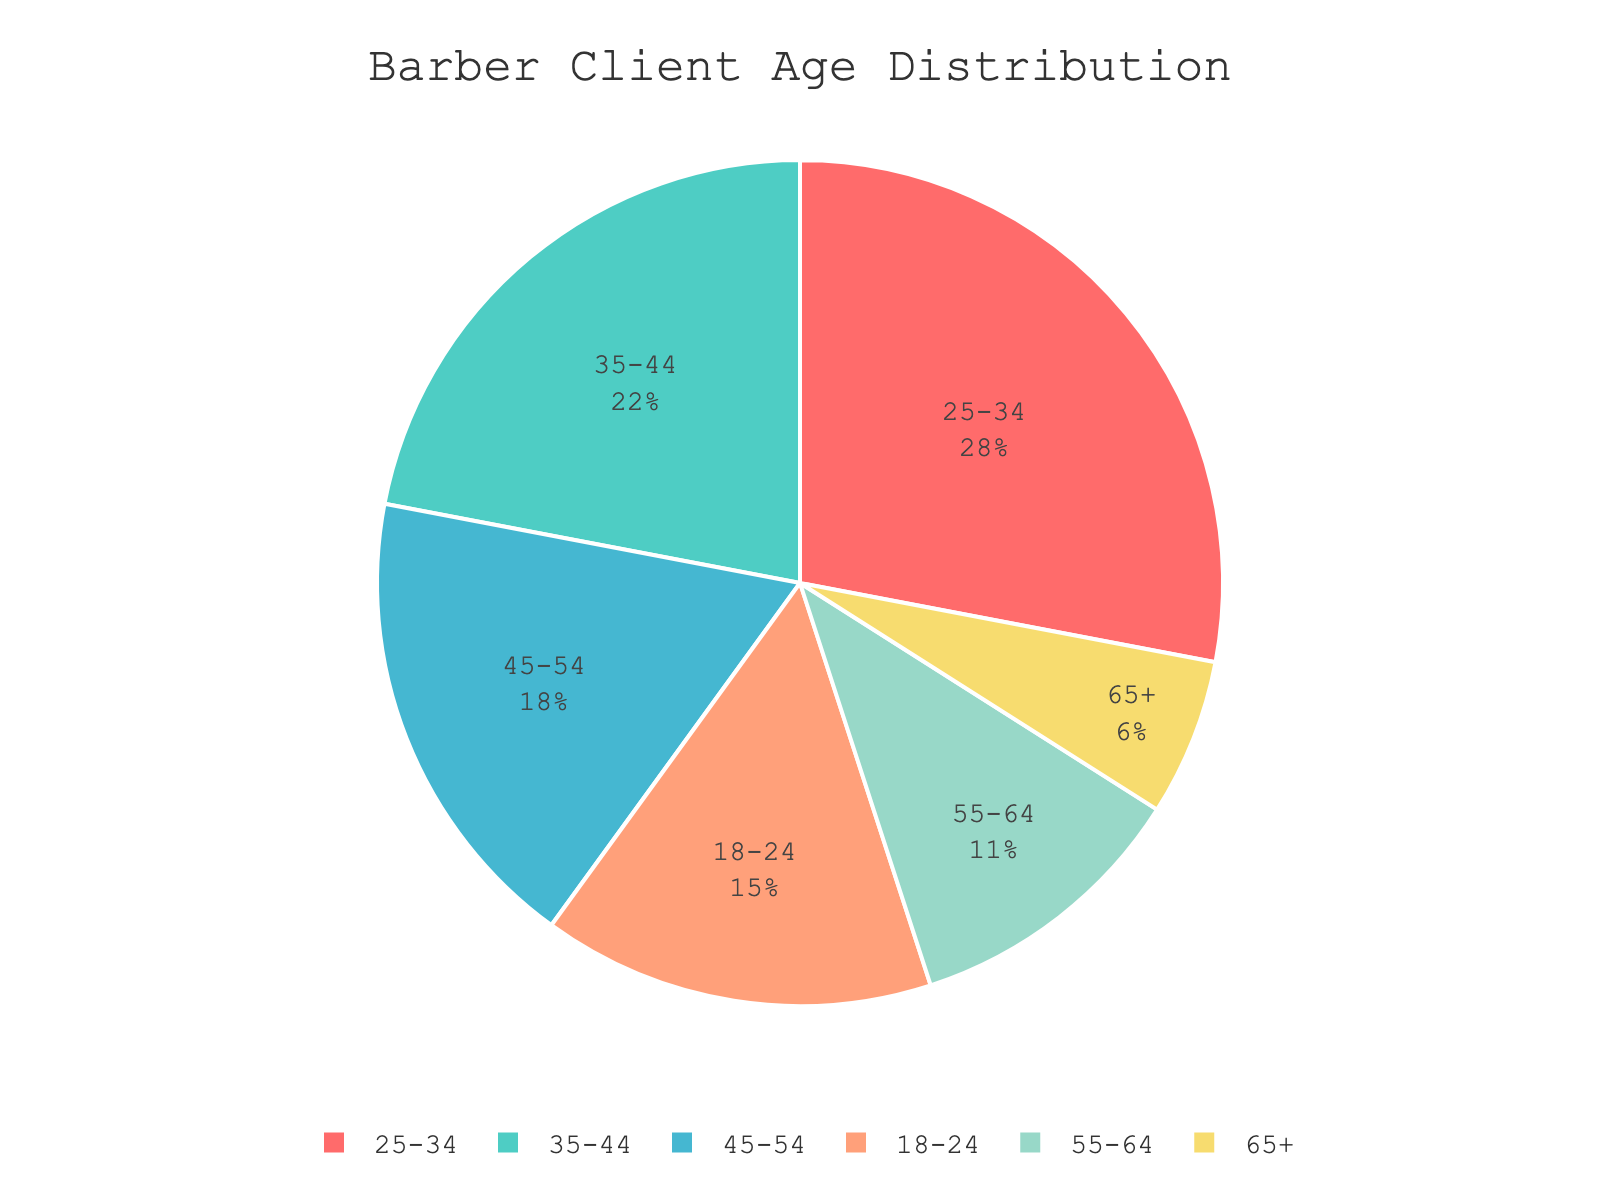Which age group makes up the largest percentage of barber clients? The figure shows a pie chart with various age groups and their percentages. By visually identifying the largest slice, we can see that the age group 25-34 has the highest value of 28%.
Answer: 25-34 What's the combined percentage of clients aged 45-54 and 55-64? By looking at the respective slices in the pie chart, the percentages are 18% for 45-54 and 11% for 55-64. Adding these values gives us 18% + 11% = 29%.
Answer: 29% Which age group has a smaller percentage of clients: 18-24 or 65+? To compare the two segments, we refer to their respective slices in the pie chart, which are 15% for 18-24 and 6% for 65+. Therefore, the 65+ group has a smaller percentage.
Answer: 65+ What is the difference in percentage between the 35-44 age group and the 55-64 age group? The figure shows 22% for the 35-44 age group and 11% for the 55-64 age group. Subtracting these values gives 22% - 11% = 11%.
Answer: 11% How much larger is the percentage of clients aged 25-34 compared to those aged 65+? By comparing the two slices, 25-34 is 28% and 65+ is 6%. The difference is 28% - 6% = 22%.
Answer: 22% Which color slice represents the clients aged 45-54? The pie chart uses distinct colors to represent different age groups. The 45-54 age group is represented by a yellow-toned slice.
Answer: yellow-toned What is the combined percentage of clients under 34 years old? The age groups under 34 years are 18-24 and 25-34. Summing their percentages, we get 15% + 28% = 43%.
Answer: 43% Are there more clients aged 18-24 or those in the 45-54 age group? The pie chart shows 15% for 18-24 and 18% for 45-54. Therefore, there are more clients aged 45-54 than 18-24.
Answer: 45-54 